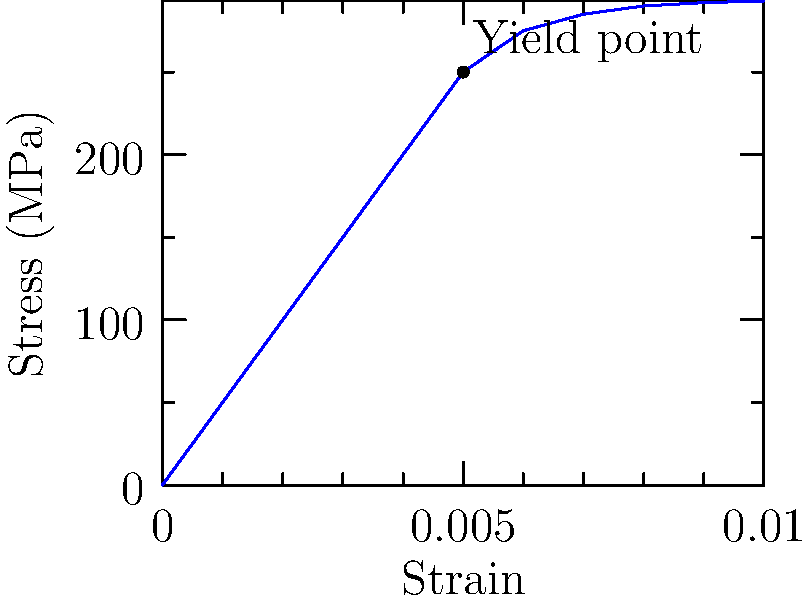Based on the stress-strain curve for scaffolding steel shown above, determine the maximum safe working load for a scaffolding support beam with a cross-sectional area of 5 cm². Assume a safety factor of 1.5 and that the yield point occurs at 250 MPa. How would you explain this calculation to a client who has suffered an injury due to scaffolding failure? To determine the maximum safe working load for the scaffolding support beam, we'll follow these steps:

1. Identify the yield strength from the stress-strain curve:
   The yield point occurs at 250 MPa (megapascals).

2. Apply the safety factor:
   Safe stress = Yield strength ÷ Safety factor
   $$ \text{Safe stress} = \frac{250 \text{ MPa}}{1.5} = 166.67 \text{ MPa} $$

3. Convert the cross-sectional area to square meters:
   $$ 5 \text{ cm}^2 = 5 \times 10^{-4} \text{ m}^2 $$

4. Calculate the maximum safe force:
   Force = Stress × Area
   $$ F = 166.67 \times 10^6 \text{ Pa} \times 5 \times 10^{-4} \text{ m}^2 = 83,335 \text{ N} $$

5. Convert the force to mass (for easier client understanding):
   $$ \text{Mass} = \frac{\text{Force}}{\text{Acceleration due to gravity}} = \frac{83,335 \text{ N}}{9.81 \text{ m/s}^2} \approx 8,495 \text{ kg} $$

Explanation to the client:
"The stress-strain curve shows how the scaffolding steel behaves under increasing load. We identified the point where the steel starts to permanently deform, called the yield point. To ensure safety, we divided this by 1.5, giving us a maximum safe stress. Considering the size of the support beam, we calculated that it should safely support about 8,495 kg or 18,728 lbs. Any load exceeding this significantly increases the risk of failure and potential injuries."
Answer: 8,495 kg (18,728 lbs) 